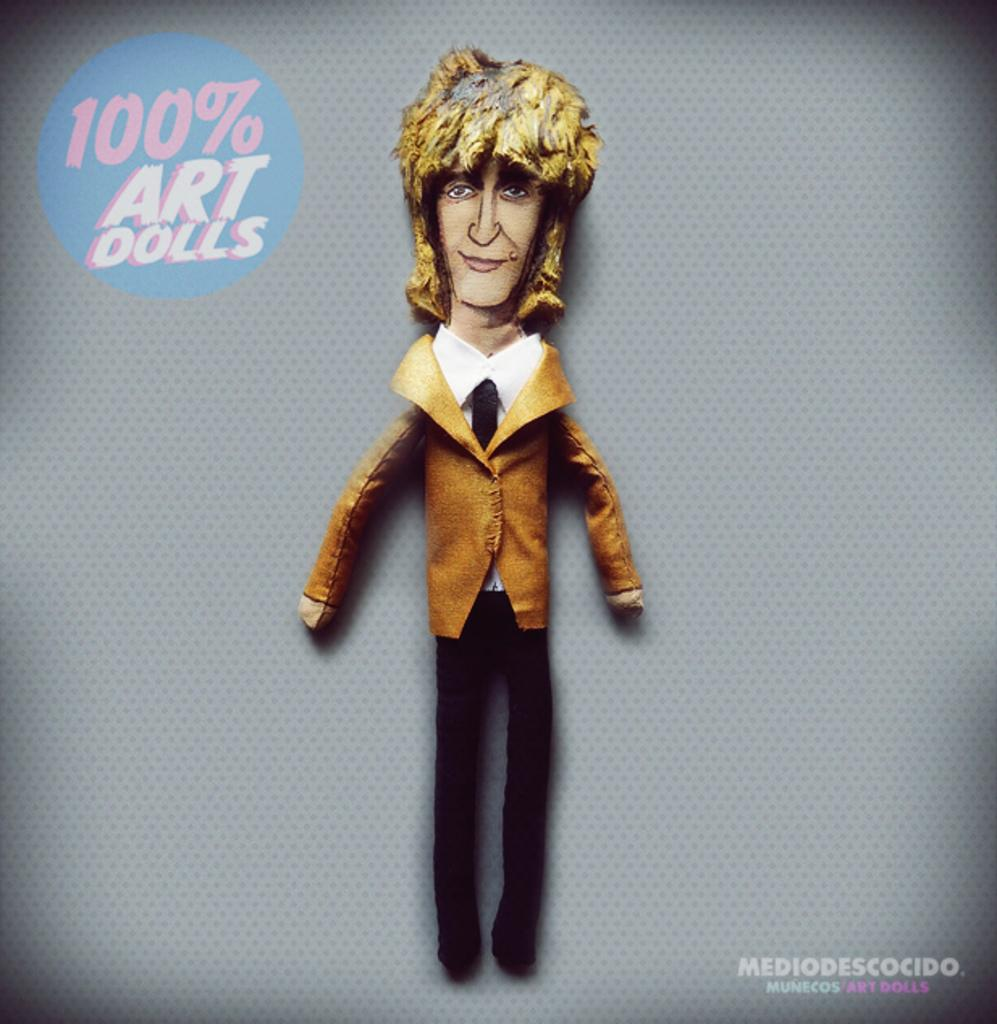What is featured on the poster in the image? The poster contains a cartoon picture. What type of text is written on the poster? There is text written on the poster. Can you describe the watermark at the bottom of the image? There is a watermark at the bottom of the image. Are there any farm animals visible in the image? No, there are no farm animals present in the image. What type of leather is used to make the doll in the image? There is no doll present in the image, and therefore no leather can be associated with it. 